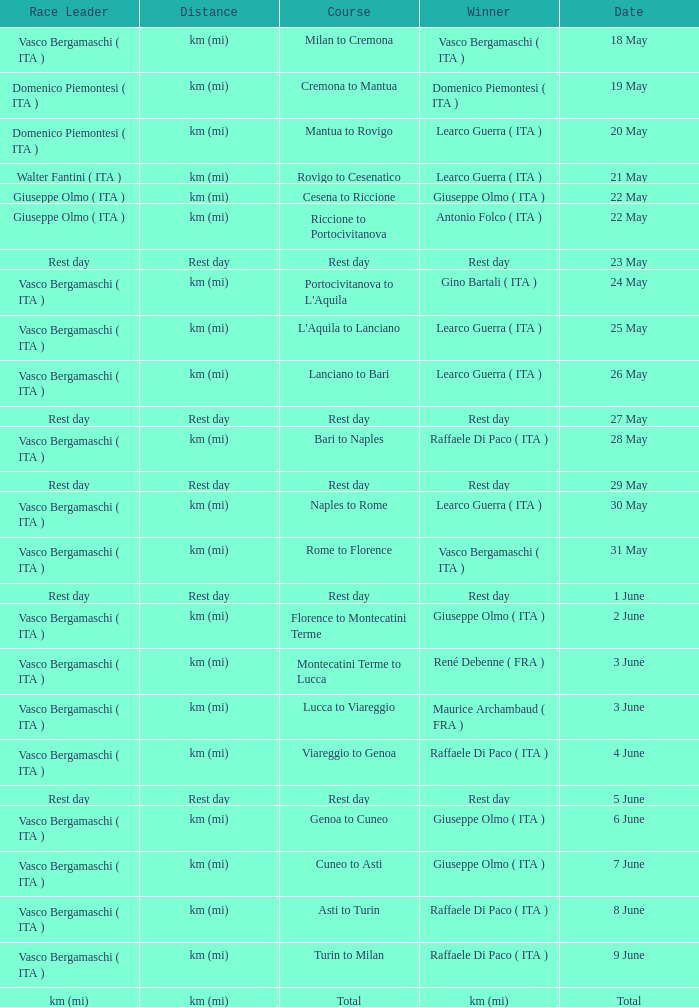Who won on 28 May? Raffaele Di Paco ( ITA ). 